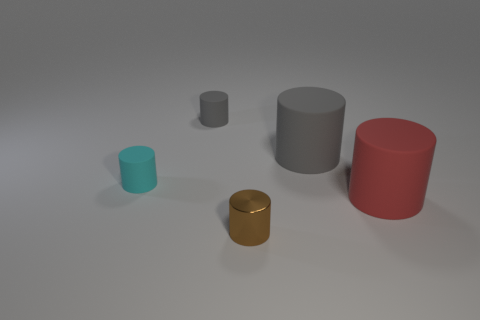What is the gray cylinder on the right side of the small metallic thing made of?
Your response must be concise. Rubber. Is the small gray rubber thing the same shape as the small metallic thing?
Make the answer very short. Yes. There is another small rubber thing that is the same shape as the cyan rubber object; what color is it?
Keep it short and to the point. Gray. Are there more rubber objects on the left side of the tiny gray rubber cylinder than large green blocks?
Provide a short and direct response. Yes. The shiny cylinder in front of the big gray cylinder is what color?
Keep it short and to the point. Brown. Does the metal object have the same size as the red thing?
Your response must be concise. No. What size is the brown thing?
Offer a terse response. Small. Are there more large rubber cylinders than tiny gray metallic balls?
Make the answer very short. Yes. What is the color of the small matte thing left of the gray cylinder that is on the left side of the gray object that is to the right of the tiny brown metallic cylinder?
Make the answer very short. Cyan. Do the big object that is behind the small cyan rubber object and the brown metal object have the same shape?
Your answer should be very brief. Yes. 